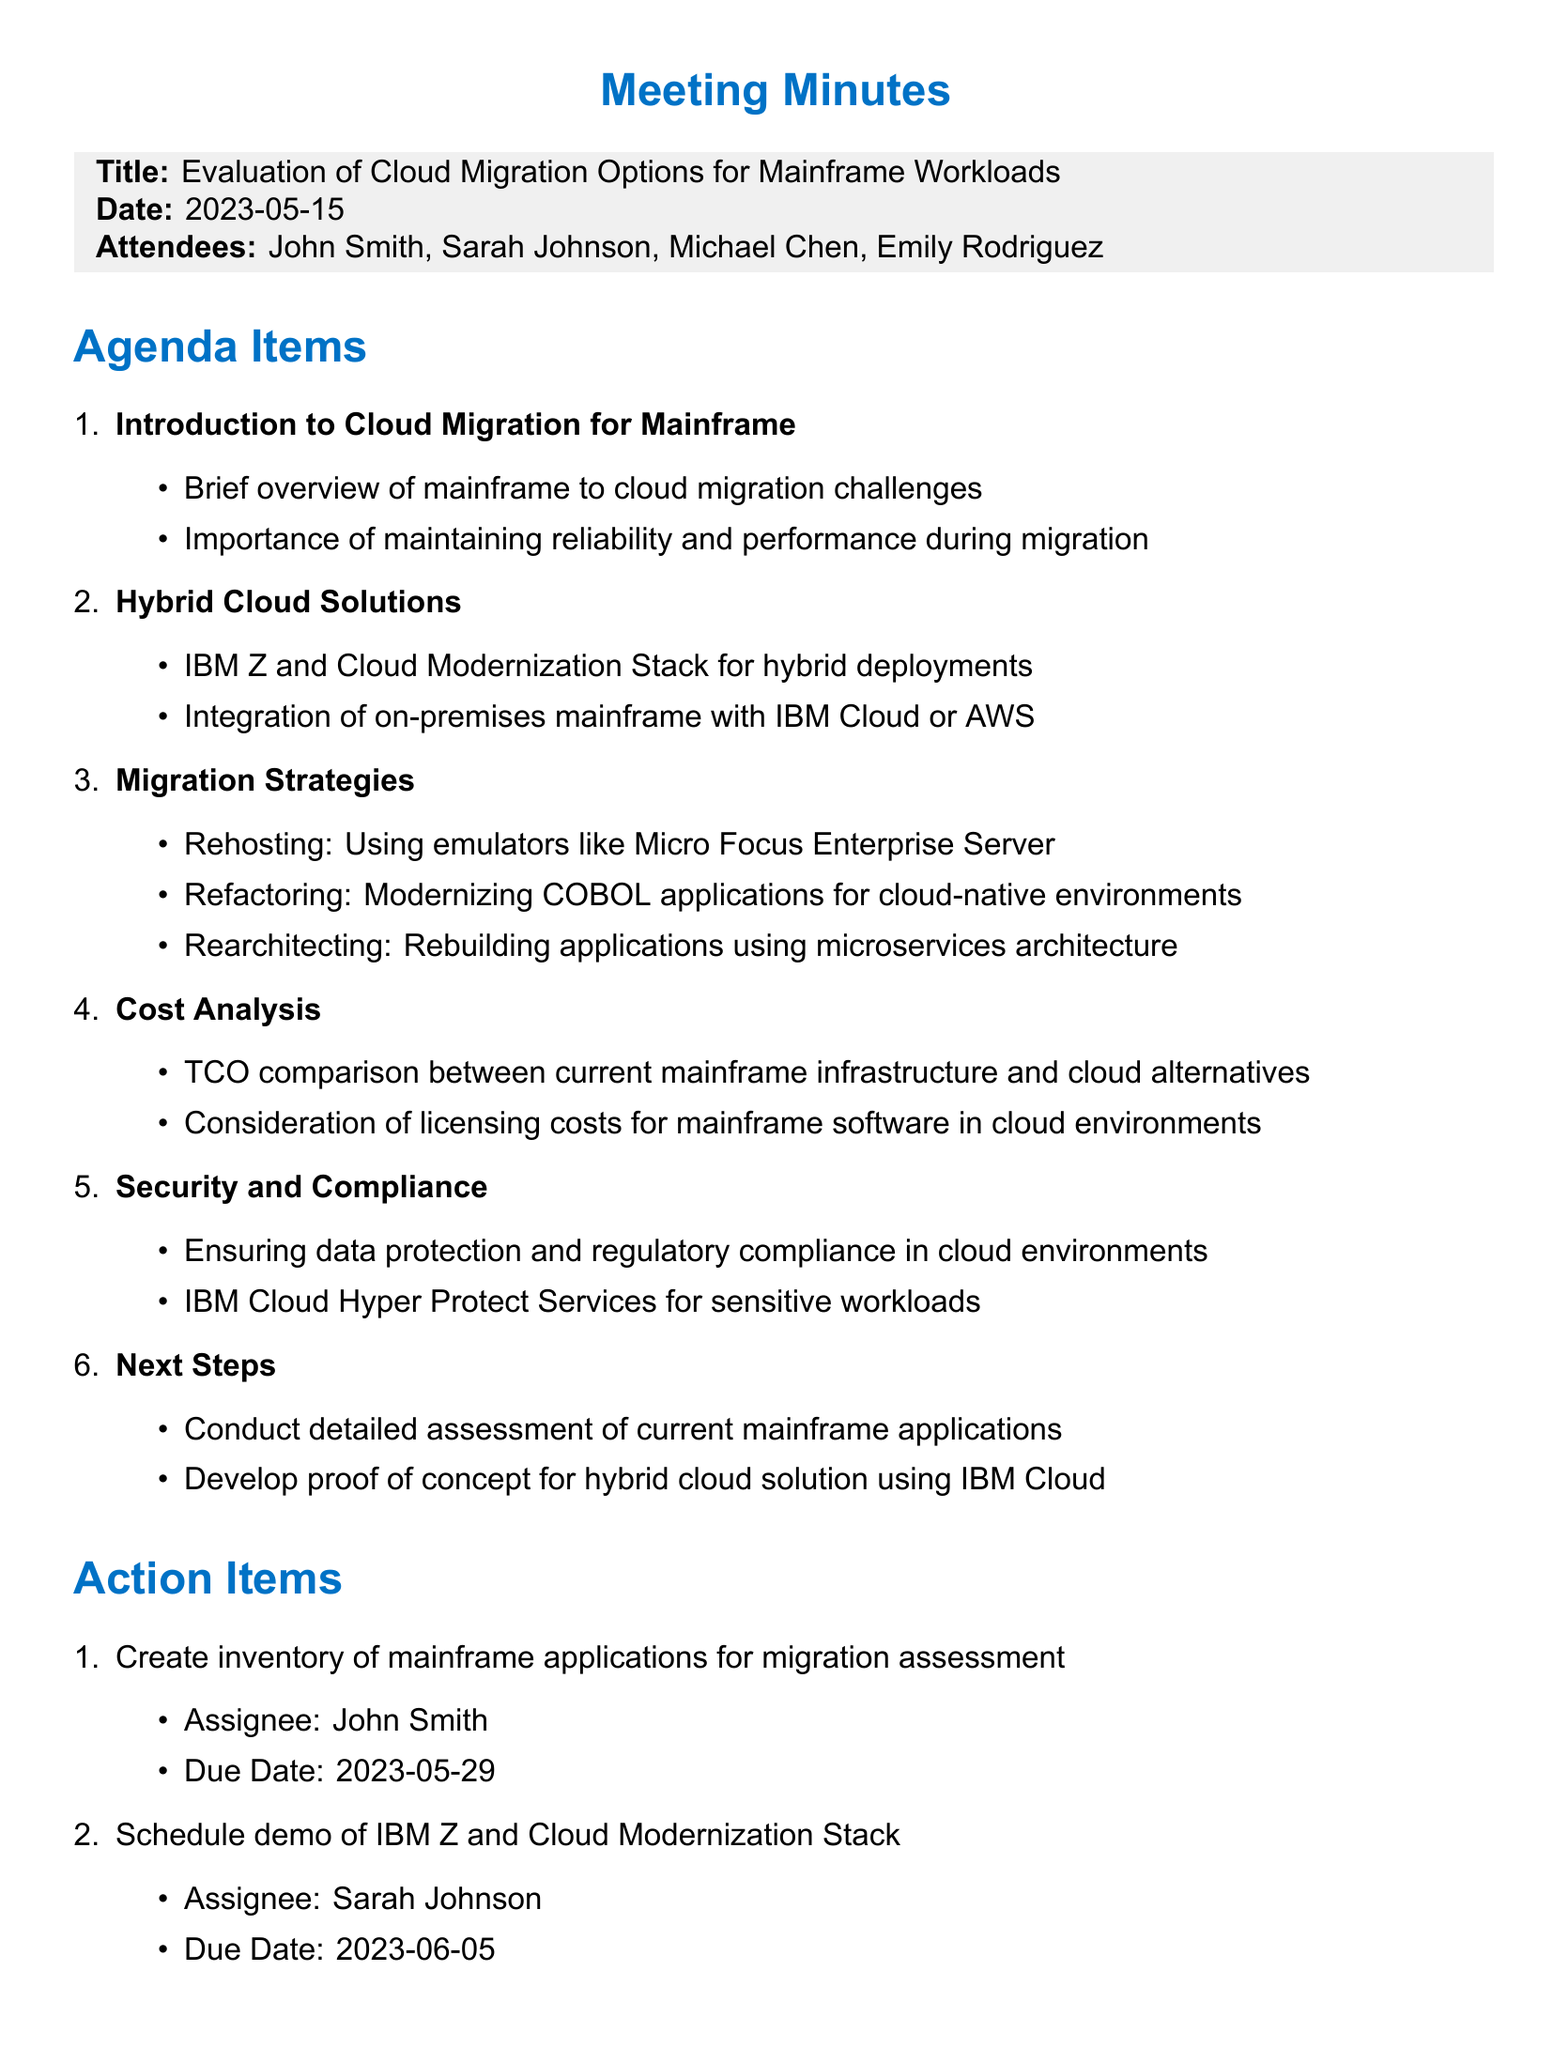What is the title of the meeting? The title of the meeting is specified at the beginning of the document.
Answer: Evaluation of Cloud Migration Options for Mainframe Workloads What date was the meeting held? The date of the meeting is mentioned in the introductory section of the document.
Answer: 2023-05-15 Who is tasked with creating the inventory of mainframe applications? The action items section specifies the assignee for the task of creating the inventory.
Answer: John Smith What is one of the key points discussed under Hybrid Cloud Solutions? The key points relating to Hybrid Cloud Solutions highlight important aspects of integration.
Answer: IBM Z and Cloud Modernization Stack for hybrid deployments What is the due date for scheduling a demo of IBM Z and Cloud Modernization Stack? This information is given in the action items, outlining the specific deadlines for tasks.
Answer: 2023-06-05 What is the main focus of the 'Security and Compliance' agenda item? The agenda item lists key topics related to security and compliance in cloud environments.
Answer: Ensuring data protection and regulatory compliance in cloud environments What type of migration strategy involves modernizing COBOL applications? The document describes different strategies related to cloud migration, focusing on modernization in this case.
Answer: Refactoring What is one of the next steps identified during the meeting? The next steps section outlines future actions to be taken after the meeting.
Answer: Conduct detailed assessment of current mainframe applications 